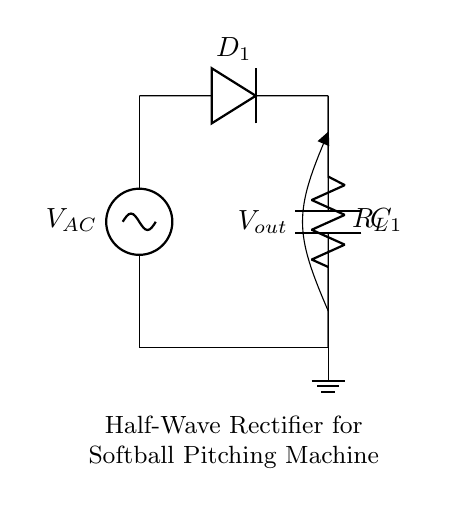What components are present in the circuit? The components include an AC source, a diode, a resistor (load), and a capacitor. Each component serves a specific function in the rectification process.
Answer: AC source, diode, resistor, capacitor What type of rectifier is depicted in the circuit? The circuit is a half-wave rectifier as indicated in the configuration where only one diode is used to allow current to flow during one half of the AC cycle.
Answer: Half-wave rectifier What is the role of the diode in this circuit? The diode allows current to flow in one direction while blocking it in the opposite direction, which is essential for converting AC to DC. This property is what rectification fundamentally relies on.
Answer: Convert AC to DC What will be the output voltage level when the input is at its peak? The output voltage will be approximately equal to the peak voltage of the AC source minus the forward voltage drop across the diode. This is due to the rectifying nature of the diode during its conduction phase.
Answer: Peak voltage minus diode drop How does the capacitor function in this circuit? The capacitor smooths out the output voltage by storing charge and releasing it when the input voltage drops, thereby reducing voltage fluctuations and providing a more stable DC output.
Answer: Smooth output voltage What happens to the output voltage during the negative half-cycle of the AC input? During the negative half-cycle, the diode becomes reverse-biased and effectively blocks current flow, resulting in zero output voltage as there is no current flowing through the load.
Answer: Zero output voltage 